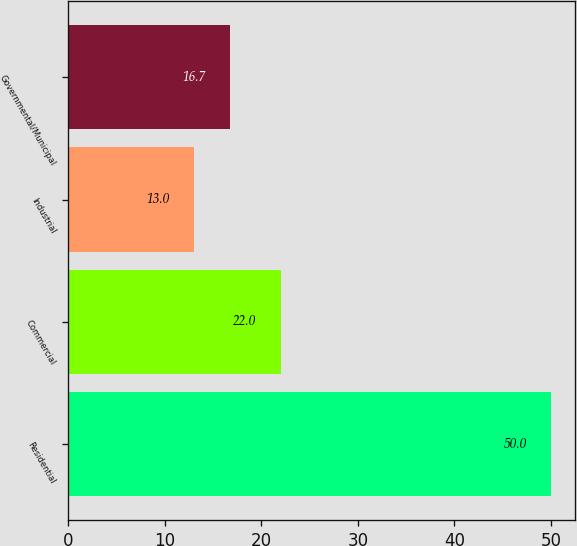Convert chart to OTSL. <chart><loc_0><loc_0><loc_500><loc_500><bar_chart><fcel>Residential<fcel>Commercial<fcel>Industrial<fcel>Governmental/Municipal<nl><fcel>50<fcel>22<fcel>13<fcel>16.7<nl></chart> 